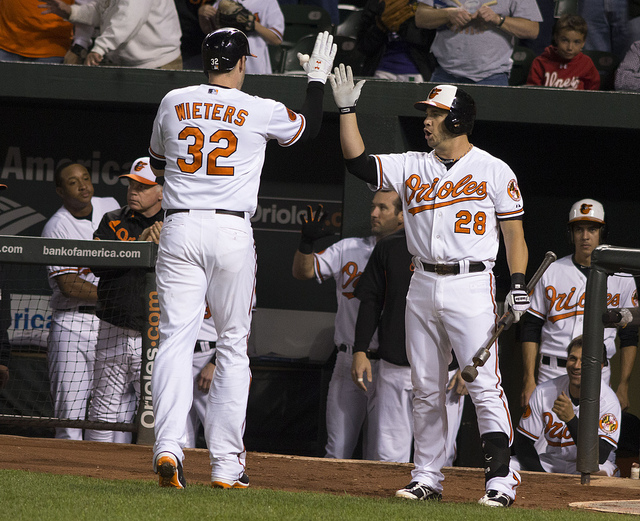Read and extract the text from this image. .com bankofamerica.com WIETERS 32 28 rica 32 